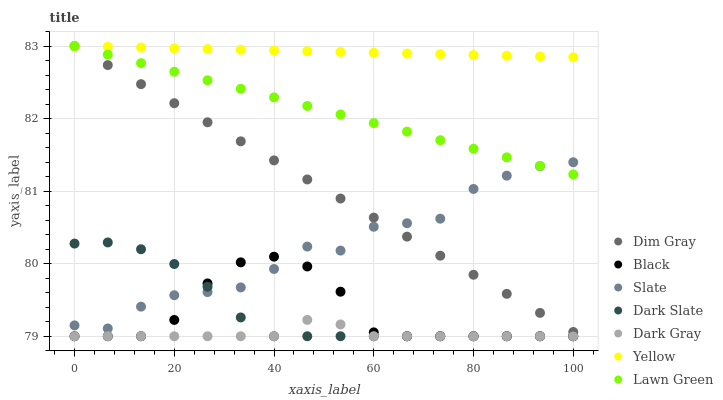Does Dark Gray have the minimum area under the curve?
Answer yes or no. Yes. Does Yellow have the maximum area under the curve?
Answer yes or no. Yes. Does Dim Gray have the minimum area under the curve?
Answer yes or no. No. Does Dim Gray have the maximum area under the curve?
Answer yes or no. No. Is Yellow the smoothest?
Answer yes or no. Yes. Is Slate the roughest?
Answer yes or no. Yes. Is Dim Gray the smoothest?
Answer yes or no. No. Is Dim Gray the roughest?
Answer yes or no. No. Does Dark Gray have the lowest value?
Answer yes or no. Yes. Does Dim Gray have the lowest value?
Answer yes or no. No. Does Yellow have the highest value?
Answer yes or no. Yes. Does Slate have the highest value?
Answer yes or no. No. Is Dark Gray less than Lawn Green?
Answer yes or no. Yes. Is Lawn Green greater than Dark Gray?
Answer yes or no. Yes. Does Slate intersect Dark Slate?
Answer yes or no. Yes. Is Slate less than Dark Slate?
Answer yes or no. No. Is Slate greater than Dark Slate?
Answer yes or no. No. Does Dark Gray intersect Lawn Green?
Answer yes or no. No. 